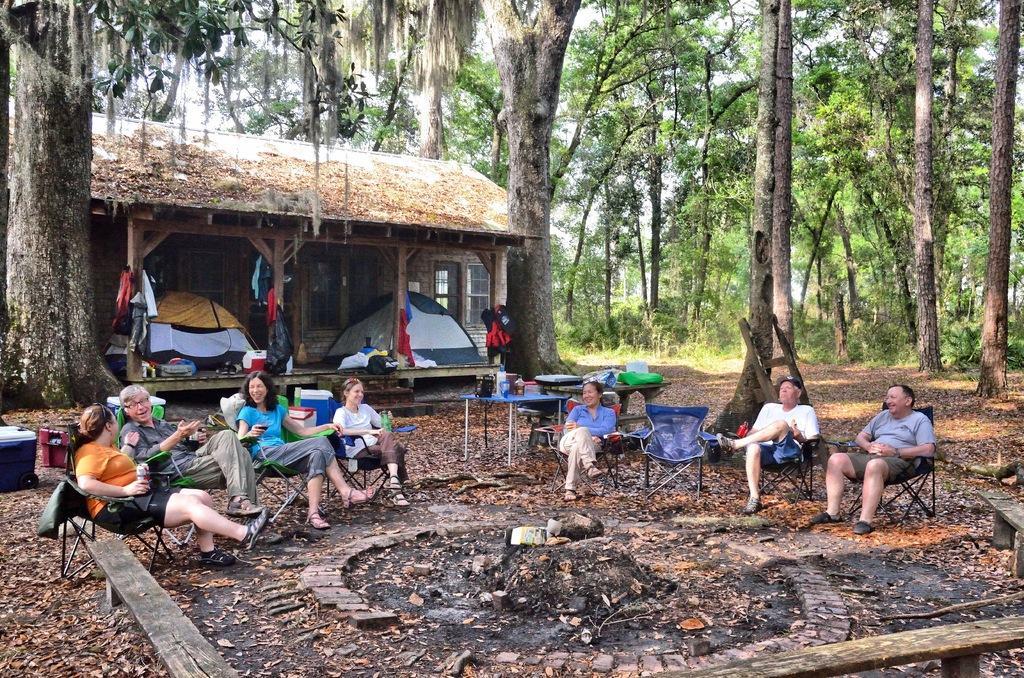Please provide a concise description of this image. In this image we can see a few people sitting on the chairs, some of them are holding glasses, there are benches, rocks, bags, boxes, there are rents, a house, clothes, there are leaves on the ground, there are plants, trees, grass, also we can see bottles on the table, and the sky. 